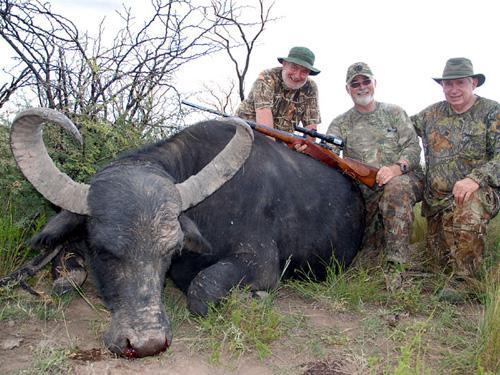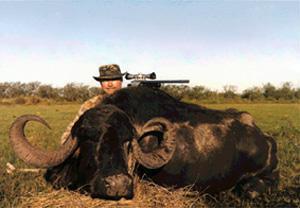The first image is the image on the left, the second image is the image on the right. For the images displayed, is the sentence "The left image contains three humans posing with a dead water buffalo." factually correct? Answer yes or no. Yes. The first image is the image on the left, the second image is the image on the right. Evaluate the accuracy of this statement regarding the images: "Three hunters with one gun pose behind a downed water buffalo in one image, and one man poses with his weapon and a dead water buffalo in the other image.". Is it true? Answer yes or no. Yes. 